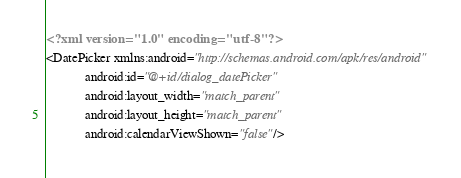<code> <loc_0><loc_0><loc_500><loc_500><_XML_><?xml version="1.0" encoding="utf-8"?>
<DatePicker xmlns:android="http://schemas.android.com/apk/res/android"
            android:id="@+id/dialog_datePicker"
            android:layout_width="match_parent"
            android:layout_height="match_parent"
            android:calendarViewShown="false"/>
</code> 